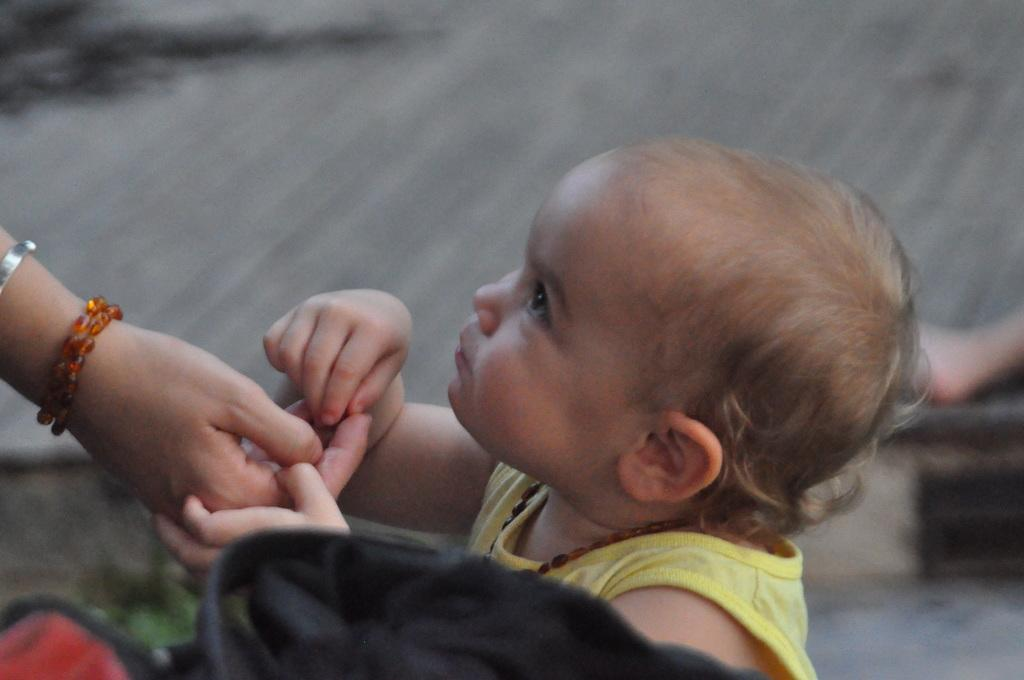What is the main subject of the image? There is a baby in the image. What is the baby doing in the image? The baby is holding the hand of a person. What objects can be seen at the bottom of the image? There are objects that look like bags at the bottom of the image. Can you describe any other visible body parts of a person in the image? There is a leg of a person visible on the right side of the image. What type of cream can be seen on the rail in the image? There is no cream or rail present in the image. What type of land is visible in the background of the image? The image does not show any land or background; it focuses on the baby and the person's hand and leg. 